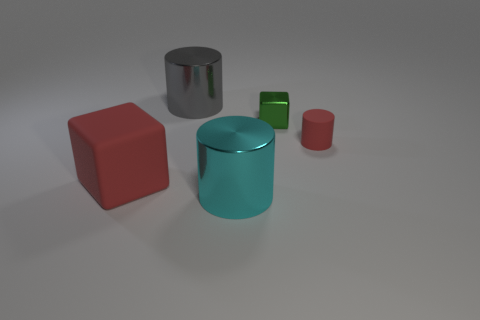There is a cube that is the same color as the tiny matte cylinder; what is it made of?
Provide a succinct answer. Rubber. How many other things are there of the same color as the big rubber object?
Offer a terse response. 1. There is a tiny matte cylinder; is it the same color as the matte thing that is to the left of the tiny matte thing?
Give a very brief answer. Yes. Is there a tiny green object that has the same shape as the gray thing?
Keep it short and to the point. No. Does the large thing that is behind the small red cylinder have the same shape as the small matte object behind the big cyan cylinder?
Provide a succinct answer. Yes. How many things are either large blue metallic objects or large rubber blocks?
Offer a very short reply. 1. What size is the red matte object that is the same shape as the gray metal thing?
Give a very brief answer. Small. Is the number of tiny matte objects on the left side of the tiny matte cylinder greater than the number of small shiny objects?
Ensure brevity in your answer.  No. Does the big cyan cylinder have the same material as the large gray cylinder?
Your answer should be compact. Yes. What number of objects are big things that are behind the cyan shiny thing or shiny cylinders behind the tiny red cylinder?
Your answer should be very brief. 2. 